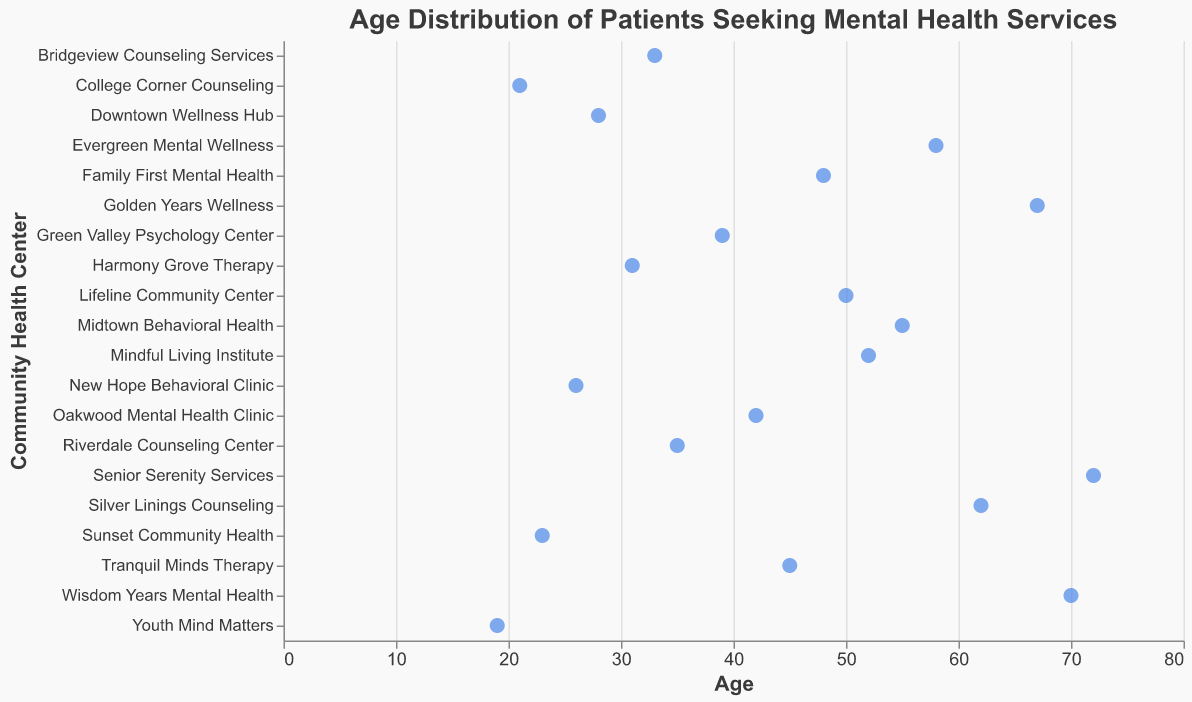What's the title of the plot? The title of the plot is located at the top and it is clearly stated in larger font than other text elements in the figure.
Answer: Age Distribution of Patients Seeking Mental Health Services Which community health center has the oldest patient and what is their age? By looking at the figure and identifying the point farthest to the right, we can see the oldest patient is at "Senior Serenity Services" at age 72.
Answer: Senior Serenity Services, 72 What's the age of the youngest patient and which center are they visiting? The youngest patient's age is found by identifying the point farthest to the left, which belongs to "Youth Mind Matters" at age 19.
Answer: 19, Youth Mind Matters Which health center has both young and old patients? By looking at the spread of points along the age axis, "College Corner Counseling" has both young (21) and relatively old (70) patients, indicating a wide age range.
Answer: College Corner Counseling What's the average age of patients at "Riverdale Counseling Center"? The plot shows a single patient from each center, so the age value for Riverdale Counseling Center is directly marked on the age axis, which is 35. Since it's only one data point, the average age is 35.
Answer: 35 How many patients seeking mental health services are over 60 years old? By examining the plot and counting points to the right of the age 60 marker, we find patients at "Golden Years Wellness", "Silver Linings Counseling", "Senior Serenity Services", and "Wisdom Years Mental Health". That's 4 patients in total.
Answer: 4 Which two centers have patients aged 50, and who are they? By checking where the age value 50 appears in the plot, we identify "Lifeline Community Center" and "Mindful Living Institute" with patients aged 50 and 52, respectively. Only Lifeline Community Center exactly matches 50.
Answer: Lifeline Community Center What is the median age of the patients? To determine the median, first, list all the ages, sort them: 19, 21, 23, 26, 28, 31, 33, 35, 39, 42, 45, 48, 50, 52, 55, 58, 62, 67, 70, 72. The median is the middle value of this set, which can be found by locating the 10th and 11th values (since 20 data points, even number). The median age is the average of 45 and 48.
Answer: 46.5 Is there a center that serves only middle-aged patients (between ages 30 and 50)? By scanning the plot for centers where all points fall between the ages of 30 and 50, Harmony Grove Therapy fits this criterion with patient age recorded at only 31.
Answer: Harmony Grove Therapy What is the spread of ages at "Midtown Behavioral Health"? Since "Midtown Behavioral Health" has a single patient represented in the list, the age marked (55) indicates no spread and is merely a single data point.
Answer: 55 